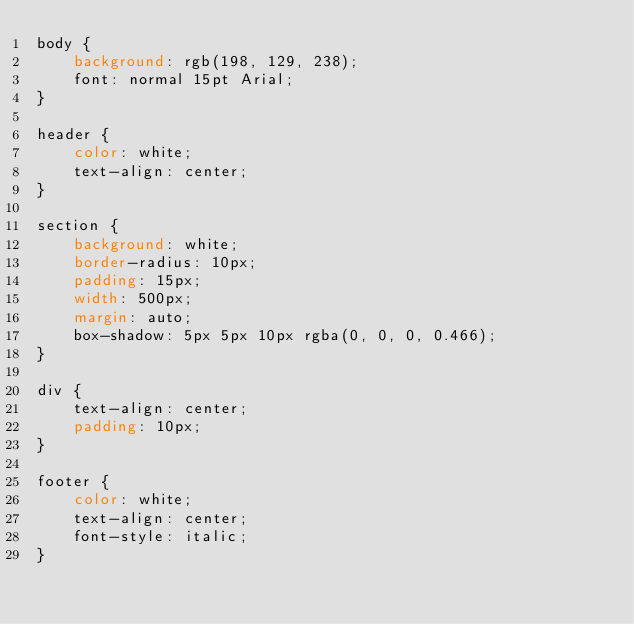<code> <loc_0><loc_0><loc_500><loc_500><_CSS_>body {
    background: rgb(198, 129, 238);
    font: normal 15pt Arial;
}

header {
    color: white;
    text-align: center;
}

section {
    background: white;
    border-radius: 10px;
    padding: 15px;
    width: 500px;
    margin: auto;
    box-shadow: 5px 5px 10px rgba(0, 0, 0, 0.466);
}

div {
    text-align: center;
    padding: 10px;
}

footer {
    color: white;
    text-align: center;
    font-style: italic;
}
</code> 